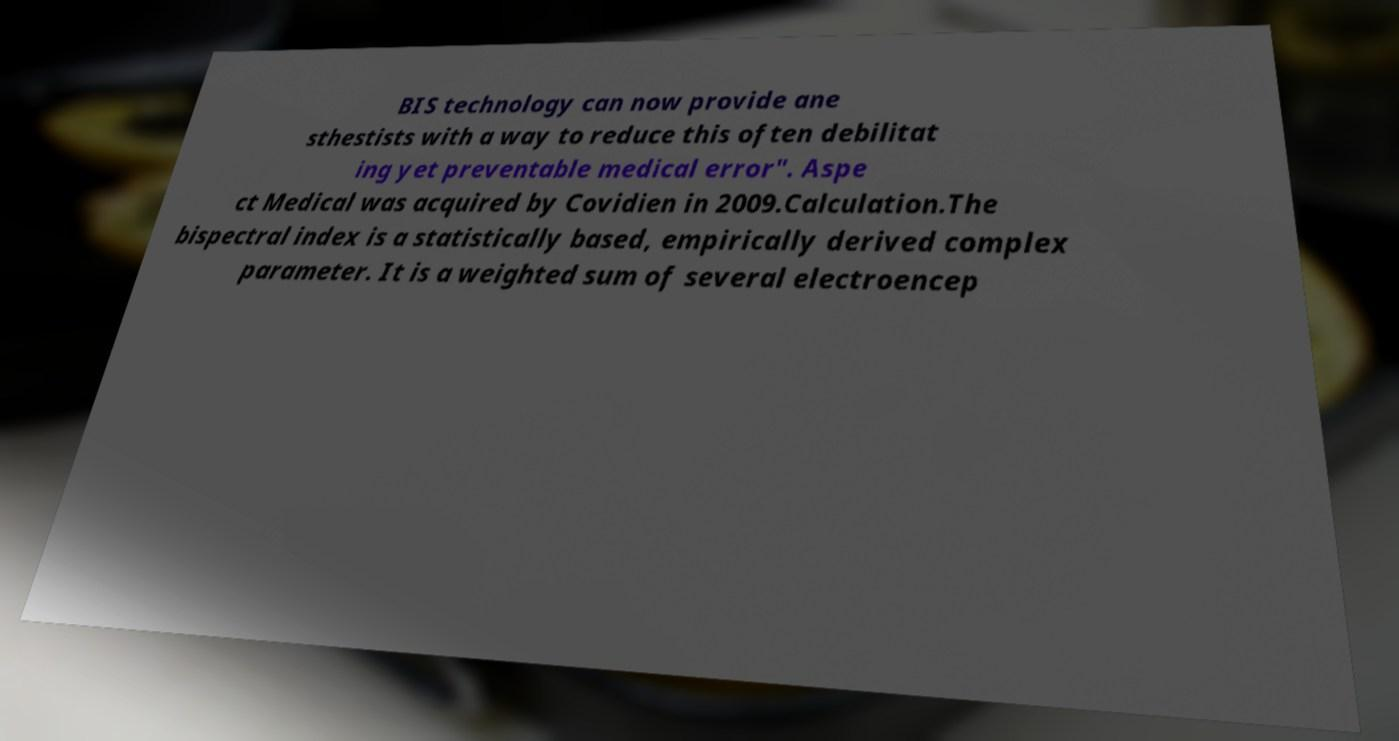There's text embedded in this image that I need extracted. Can you transcribe it verbatim? BIS technology can now provide ane sthestists with a way to reduce this often debilitat ing yet preventable medical error". Aspe ct Medical was acquired by Covidien in 2009.Calculation.The bispectral index is a statistically based, empirically derived complex parameter. It is a weighted sum of several electroencep 